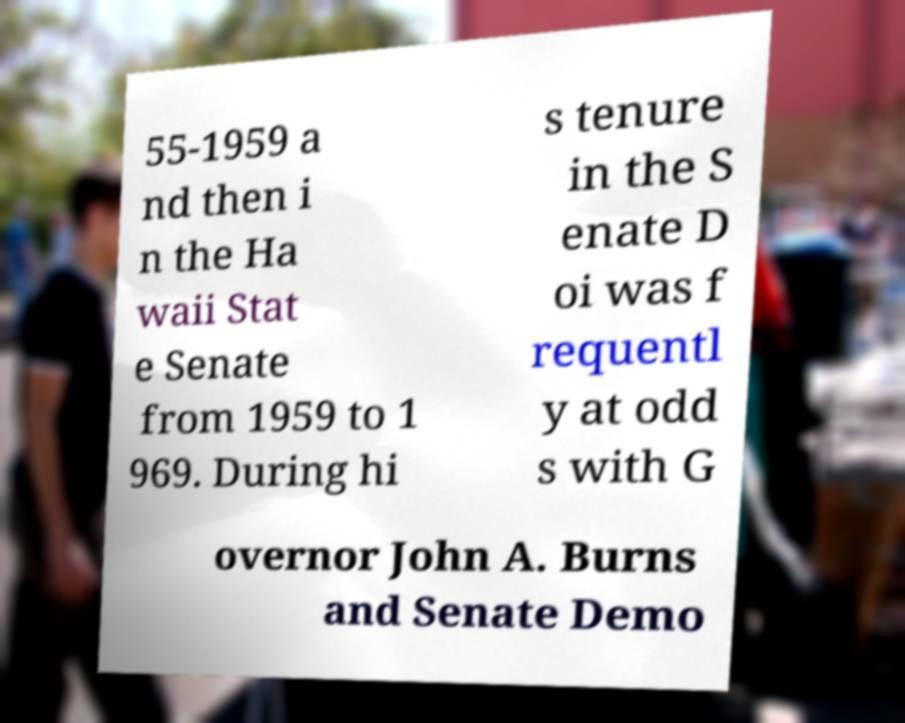I need the written content from this picture converted into text. Can you do that? 55-1959 a nd then i n the Ha waii Stat e Senate from 1959 to 1 969. During hi s tenure in the S enate D oi was f requentl y at odd s with G overnor John A. Burns and Senate Demo 